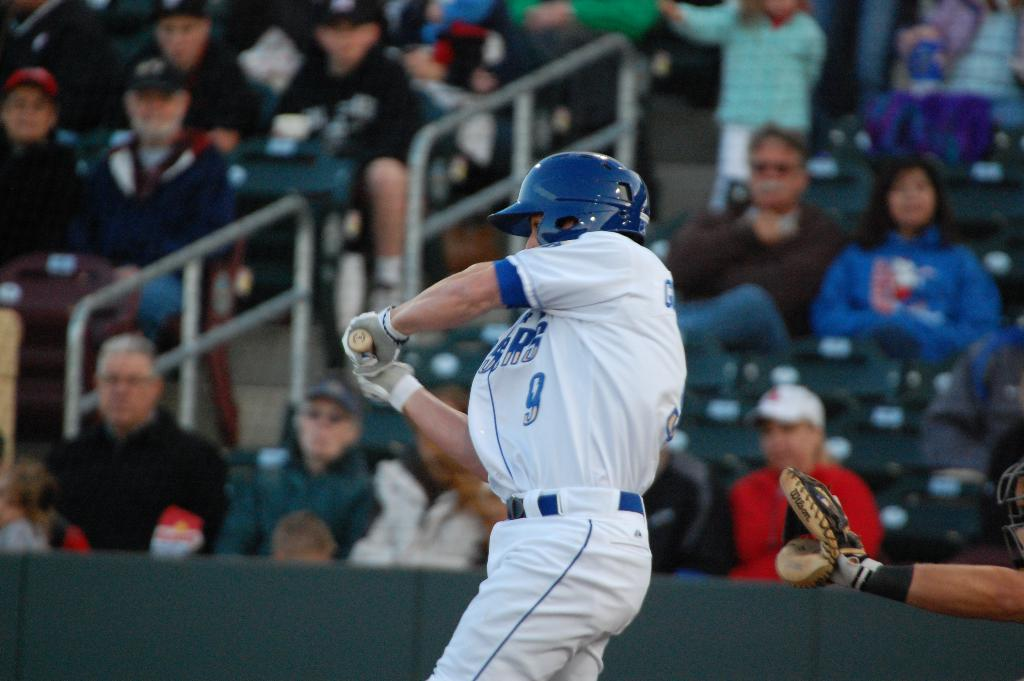<image>
Describe the image concisely. a baseball player with a blue hat and number 9 on his uniform ready to hit the ball, with the fans watching him in the stands. 